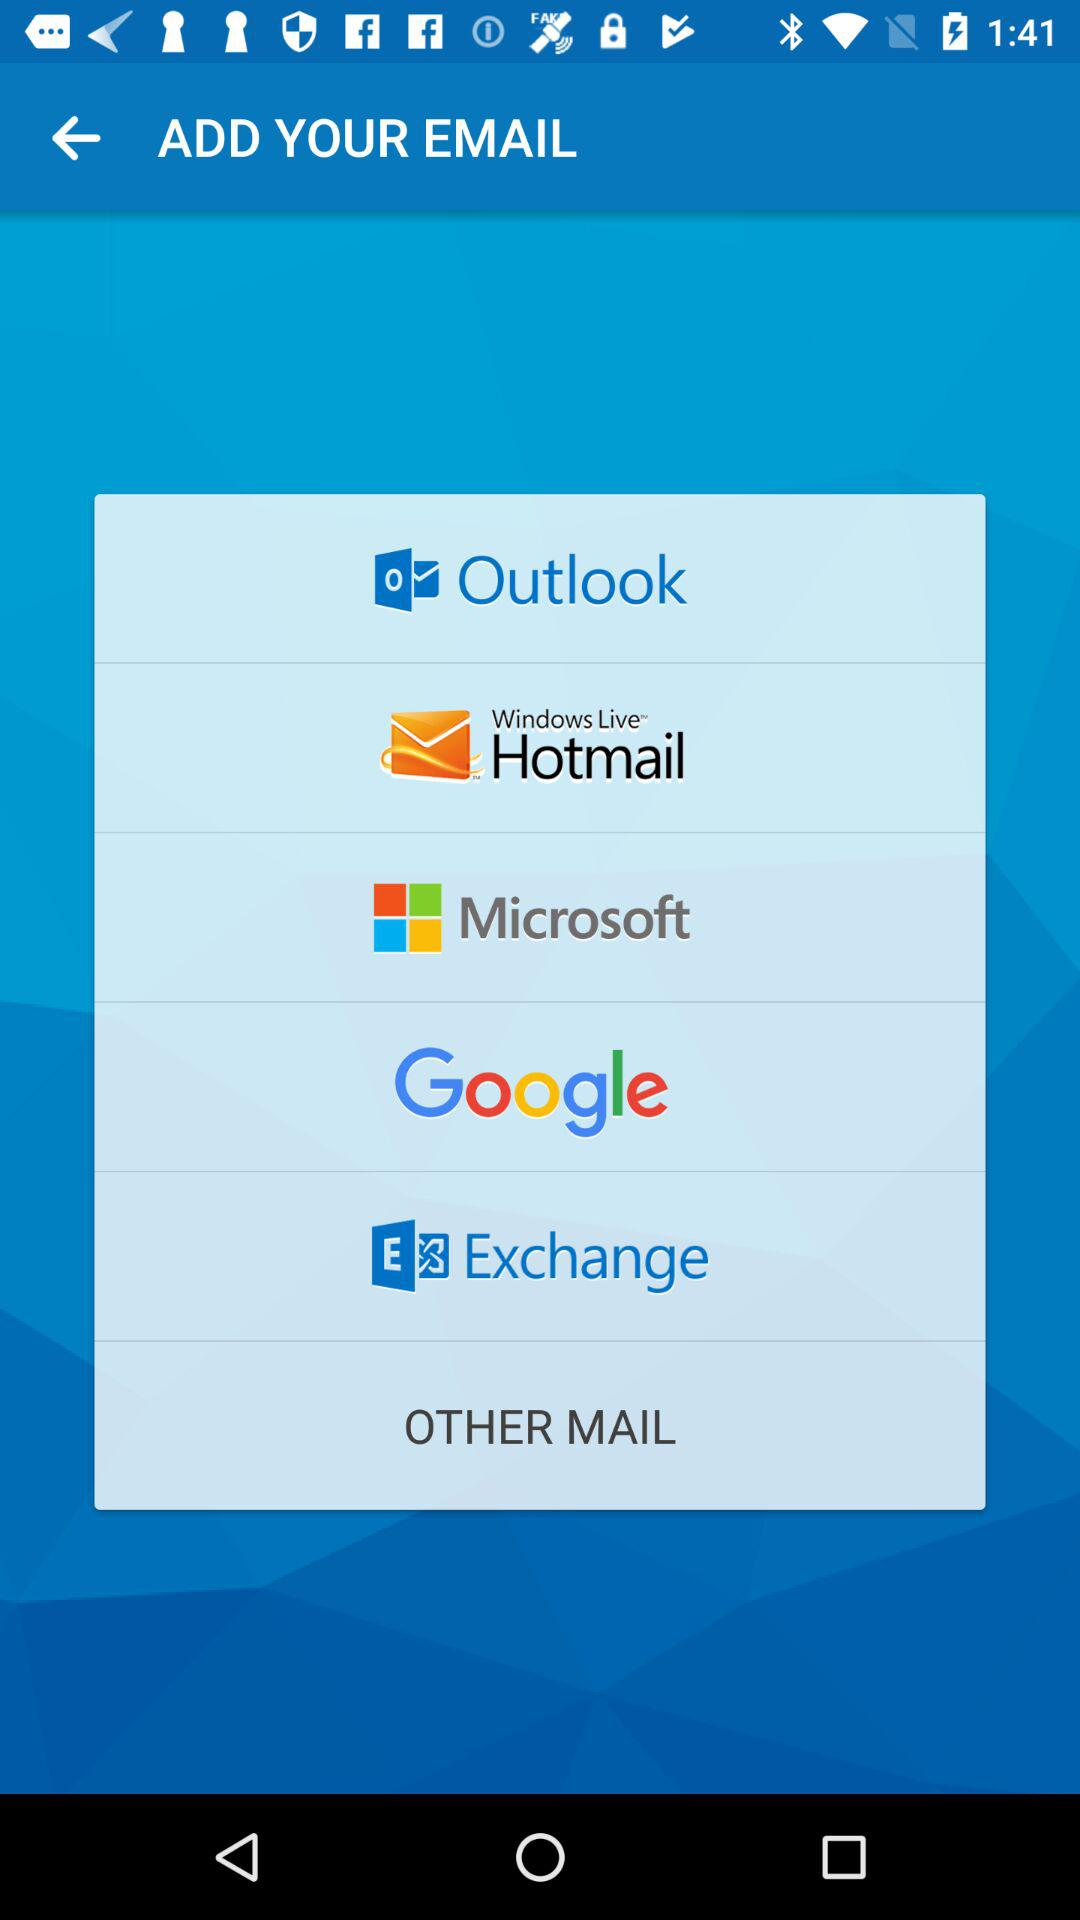What are the available apps? The available apps are "Outlook", "Windows Live Hotmail", "Microsoft", "Google" and "Exchange". 